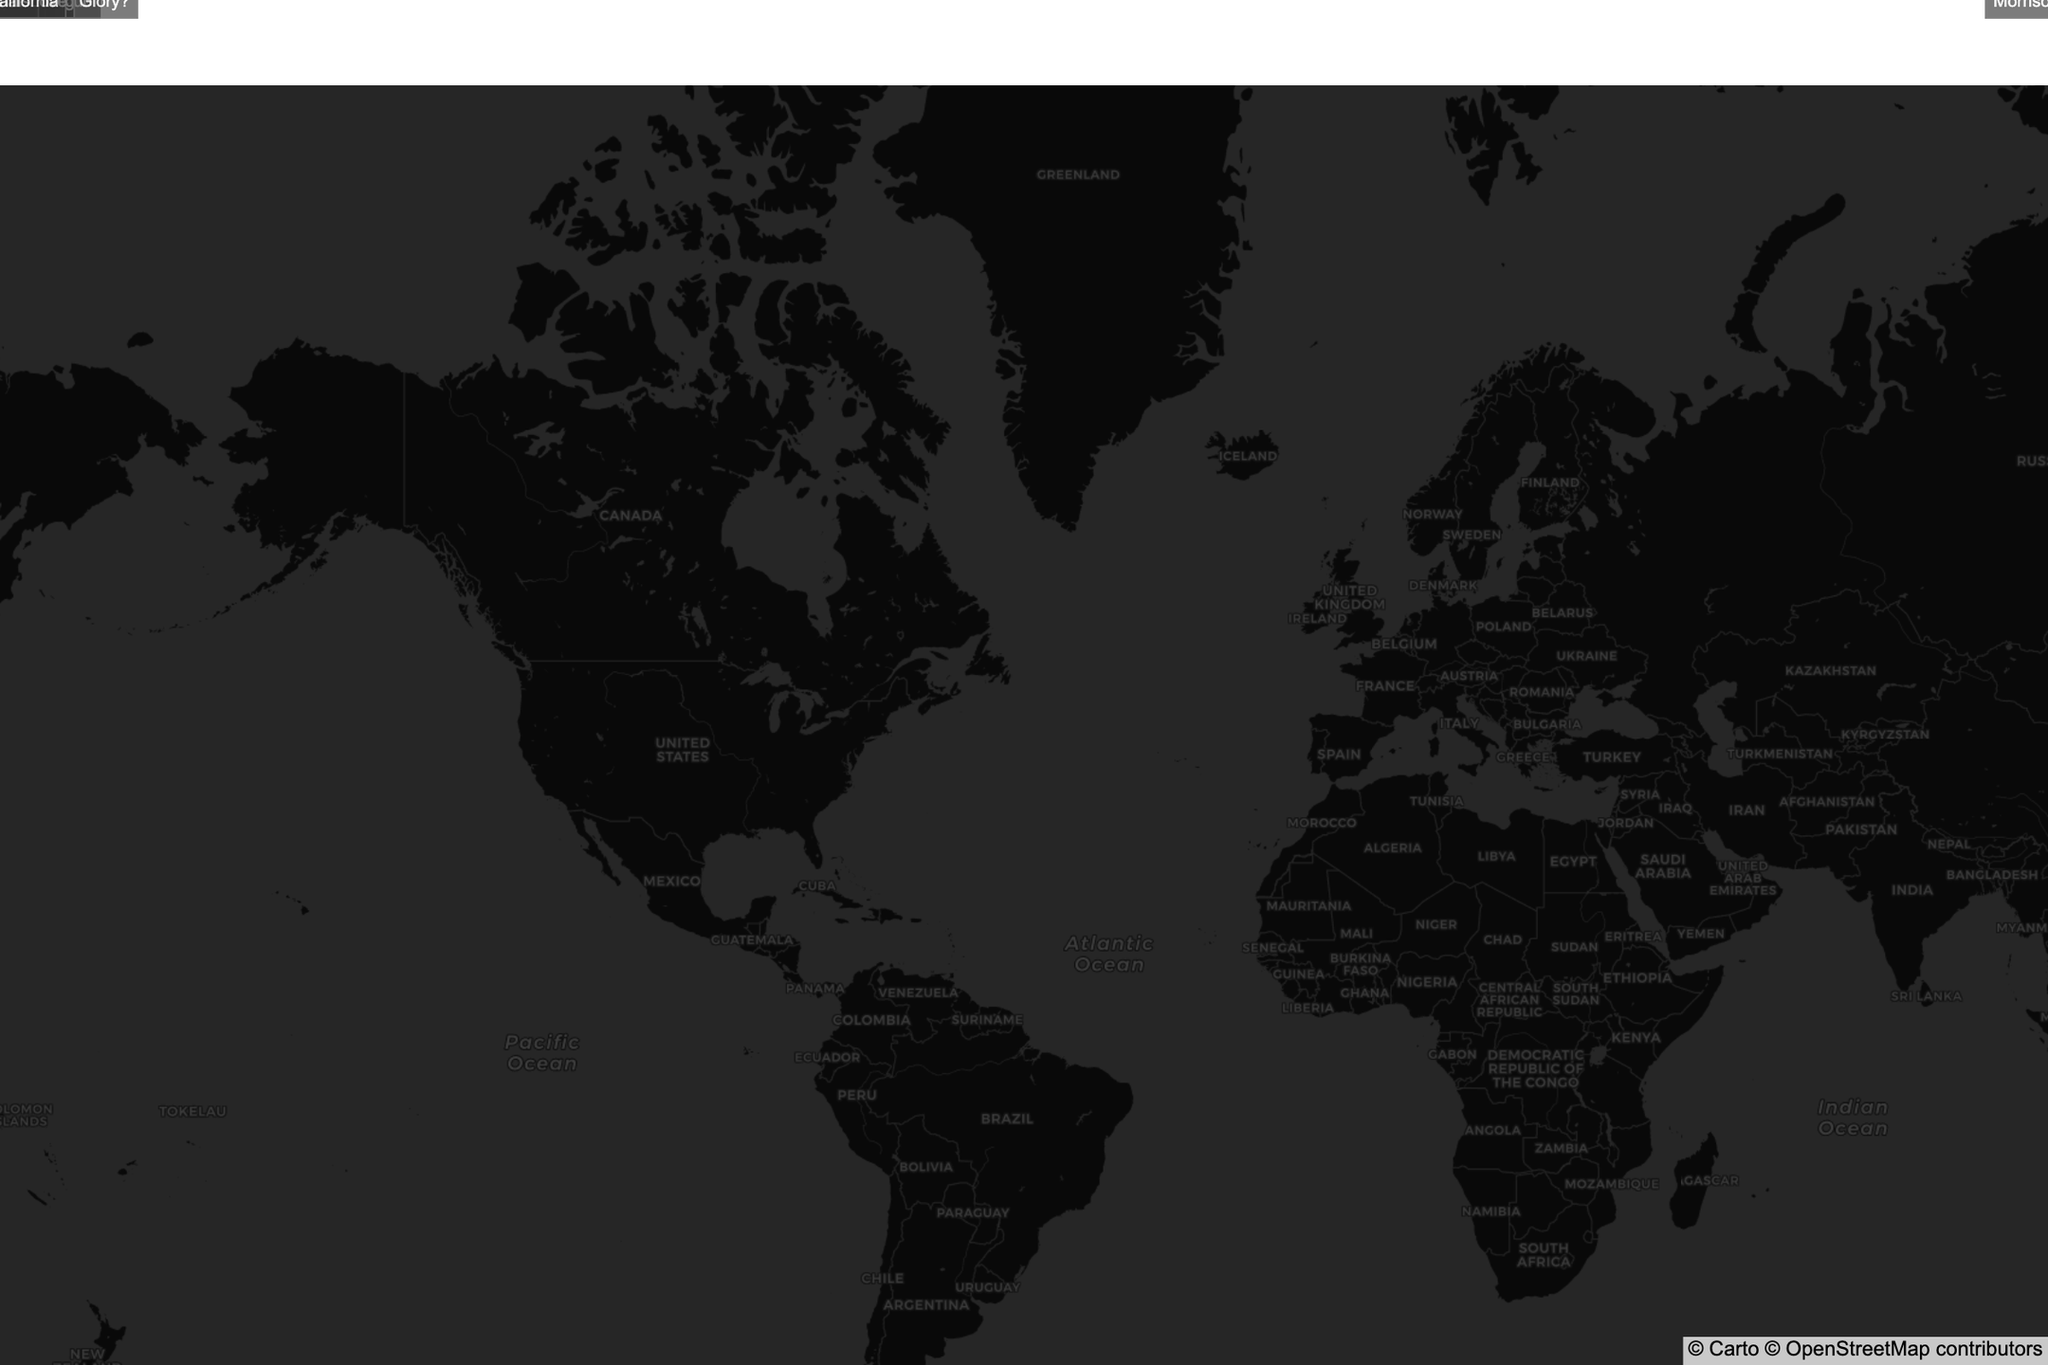What's the title of the map? The title is displayed prominently at the top of the map. It reads "Iconic Album Cover Photo Shoot Locations."
Answer: Iconic Album Cover Photo Shoot Locations How many album photo shoot locations are represented on the map? By counting the number of distinct markers, one can see there are 10 different locations represented on the map.
Answer: 10 Which album was shot in the Mojave Desert in California? Hover over the marker in the Mojave Desert in California to see details of the album "Hotel California" by The Eagles.
Answer: Hotel California by The Eagles Which two locations are the closest to each other in London? Both "London Abbey Road" and "Primrose Hill London" are in London. Looking at the map's markers and annotations, they are the closest to each other geographically.
Answer: London Abbey Road and Primrose Hill London Between "The Beatles" and "Pink Floyd," whose album cover photo shoot is located further south in London? By comparing the latitude values, "London Abbey Road" (51.5320) for The Beatles and "Battersea Power Station London" (51.4815) for Pink Floyd, we see that Pink Floyd's location is further south.
Answer: Pink Floyd Which album cover photo shoot location has the highest latitude value? By examining the latitude values, "Windermere Lake District" with a latitude of 54.3781 has the highest latitude value.
Answer: Windermere Lake District How many albums in the dataset were shot in locations outside of the United States and the United Kingdom? Locations outside the U.S. and U.K. are "Havana" and "Paris." Therefore, 2 album covers were shot outside these countries.
Answer: 2 Of the albums "Abbey Road" by The Beatles and "Buena Vista Social Club" by Buena Vista Social Club, which was released more recently? "Abbey Road" was released in 1969 and "Buena Vista Social Club" in 1997. The latter was released more recently.
Answer: Buena Vista Social Club Which album cover photo shoot location is geographically closest to the equator? With coordinates close to the equator (lower latitude values), Havana (Latitude: 23.1136) is the closest.
Answer: Havana 